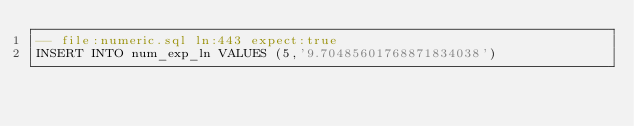Convert code to text. <code><loc_0><loc_0><loc_500><loc_500><_SQL_>-- file:numeric.sql ln:443 expect:true
INSERT INTO num_exp_ln VALUES (5,'9.70485601768871834038')
</code> 